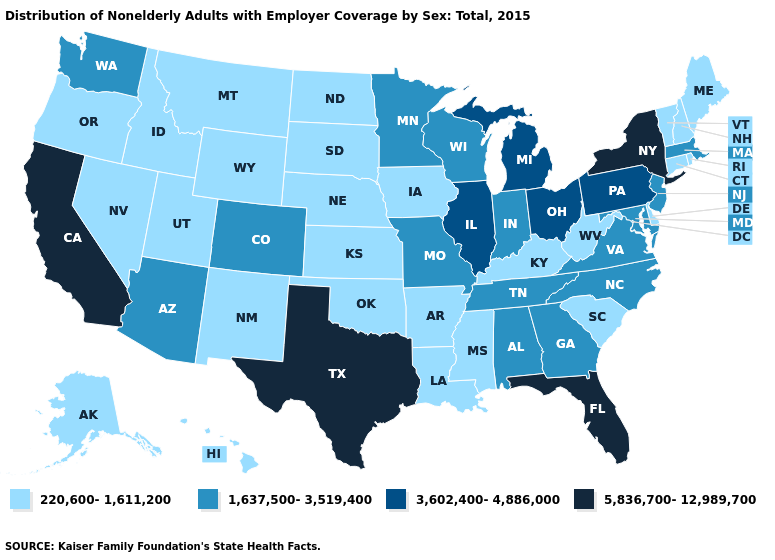What is the highest value in the MidWest ?
Concise answer only. 3,602,400-4,886,000. Which states hav the highest value in the South?
Write a very short answer. Florida, Texas. What is the value of North Carolina?
Write a very short answer. 1,637,500-3,519,400. What is the value of Louisiana?
Keep it brief. 220,600-1,611,200. Among the states that border Arizona , does Utah have the lowest value?
Keep it brief. Yes. Does Colorado have the same value as Virginia?
Be succinct. Yes. Name the states that have a value in the range 3,602,400-4,886,000?
Keep it brief. Illinois, Michigan, Ohio, Pennsylvania. Which states have the lowest value in the USA?
Answer briefly. Alaska, Arkansas, Connecticut, Delaware, Hawaii, Idaho, Iowa, Kansas, Kentucky, Louisiana, Maine, Mississippi, Montana, Nebraska, Nevada, New Hampshire, New Mexico, North Dakota, Oklahoma, Oregon, Rhode Island, South Carolina, South Dakota, Utah, Vermont, West Virginia, Wyoming. Is the legend a continuous bar?
Be succinct. No. Among the states that border Iowa , does Illinois have the highest value?
Quick response, please. Yes. What is the value of Massachusetts?
Concise answer only. 1,637,500-3,519,400. Name the states that have a value in the range 220,600-1,611,200?
Be succinct. Alaska, Arkansas, Connecticut, Delaware, Hawaii, Idaho, Iowa, Kansas, Kentucky, Louisiana, Maine, Mississippi, Montana, Nebraska, Nevada, New Hampshire, New Mexico, North Dakota, Oklahoma, Oregon, Rhode Island, South Carolina, South Dakota, Utah, Vermont, West Virginia, Wyoming. What is the value of New Mexico?
Concise answer only. 220,600-1,611,200. Does Alabama have the same value as Kansas?
Give a very brief answer. No. Name the states that have a value in the range 220,600-1,611,200?
Give a very brief answer. Alaska, Arkansas, Connecticut, Delaware, Hawaii, Idaho, Iowa, Kansas, Kentucky, Louisiana, Maine, Mississippi, Montana, Nebraska, Nevada, New Hampshire, New Mexico, North Dakota, Oklahoma, Oregon, Rhode Island, South Carolina, South Dakota, Utah, Vermont, West Virginia, Wyoming. 